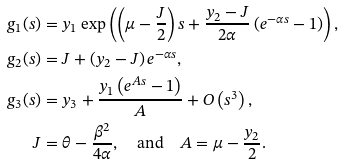Convert formula to latex. <formula><loc_0><loc_0><loc_500><loc_500>g _ { 1 } ( s ) & = y _ { 1 } \exp \left ( \left ( \mu - \frac { J } { 2 } \right ) s + \frac { y _ { 2 } - J } { 2 \alpha } \left ( e ^ { - \alpha s } - 1 \right ) \right ) , \\ g _ { 2 } ( s ) & = J + \left ( y _ { 2 } - J \right ) e ^ { - \alpha s } , \\ g _ { 3 } ( s ) & = y _ { 3 } + \frac { y _ { 1 } \left ( e ^ { A s } - 1 \right ) } { A } + O \left ( s ^ { 3 } \right ) , \\ J & = \theta - \frac { \beta ^ { 2 } } { 4 \alpha } , \quad \text {and} \quad A = \mu - \frac { y _ { 2 } } { 2 } .</formula> 